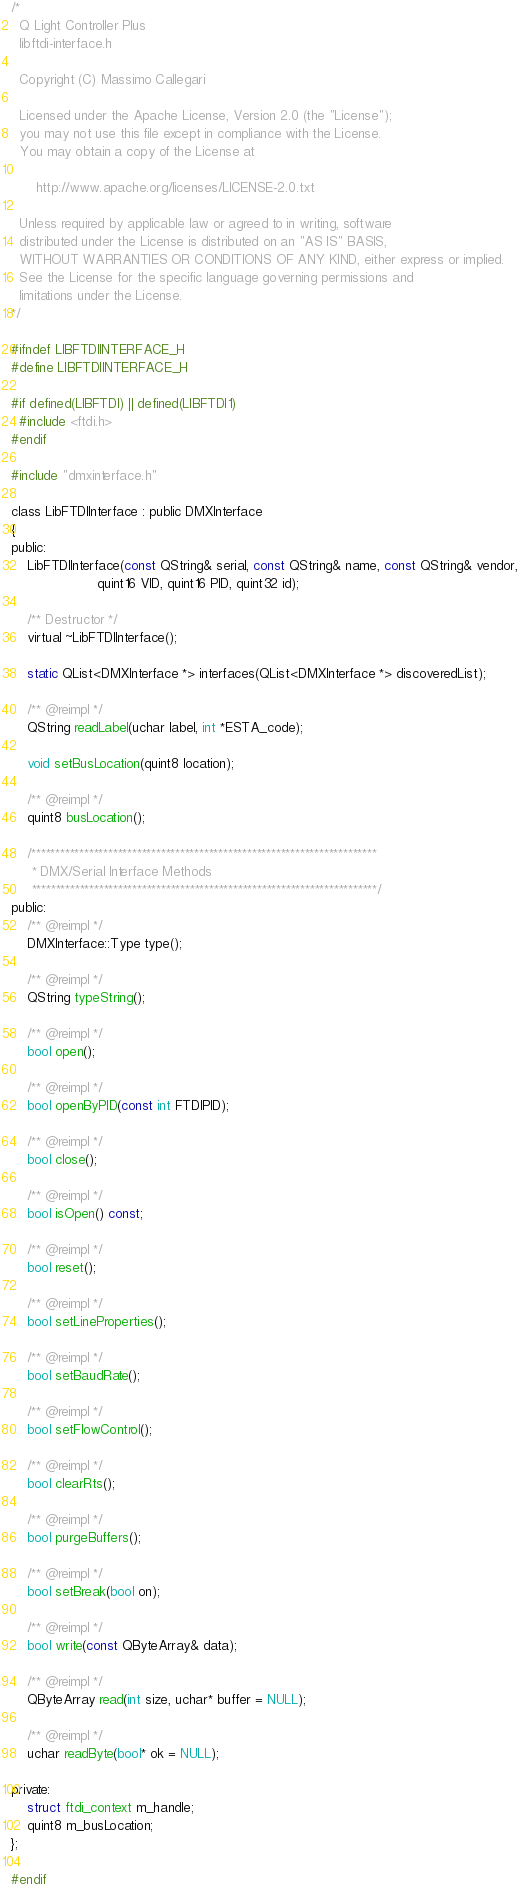Convert code to text. <code><loc_0><loc_0><loc_500><loc_500><_C_>/*
  Q Light Controller Plus
  libftdi-interface.h

  Copyright (C) Massimo Callegari

  Licensed under the Apache License, Version 2.0 (the "License");
  you may not use this file except in compliance with the License.
  You may obtain a copy of the License at

      http://www.apache.org/licenses/LICENSE-2.0.txt

  Unless required by applicable law or agreed to in writing, software
  distributed under the License is distributed on an "AS IS" BASIS,
  WITHOUT WARRANTIES OR CONDITIONS OF ANY KIND, either express or implied.
  See the License for the specific language governing permissions and
  limitations under the License.
*/

#ifndef LIBFTDIINTERFACE_H
#define LIBFTDIINTERFACE_H

#if defined(LIBFTDI) || defined(LIBFTDI1)
  #include <ftdi.h>
#endif

#include "dmxinterface.h"

class LibFTDIInterface : public DMXInterface
{
public:
    LibFTDIInterface(const QString& serial, const QString& name, const QString& vendor,
                     quint16 VID, quint16 PID, quint32 id);

    /** Destructor */
    virtual ~LibFTDIInterface();

    static QList<DMXInterface *> interfaces(QList<DMXInterface *> discoveredList);

    /** @reimpl */
    QString readLabel(uchar label, int *ESTA_code);

    void setBusLocation(quint8 location);

    /** @reimpl */
    quint8 busLocation();

    /************************************************************************
     * DMX/Serial Interface Methods
     ************************************************************************/
public:
    /** @reimpl */
    DMXInterface::Type type();

    /** @reimpl */
    QString typeString();

    /** @reimpl */
    bool open();

    /** @reimpl */
    bool openByPID(const int FTDIPID);

    /** @reimpl */
    bool close();

    /** @reimpl */
    bool isOpen() const;

    /** @reimpl */
    bool reset();

    /** @reimpl */
    bool setLineProperties();

    /** @reimpl */
    bool setBaudRate();

    /** @reimpl */
    bool setFlowControl();

    /** @reimpl */
    bool clearRts();

    /** @reimpl */
    bool purgeBuffers();

    /** @reimpl */
    bool setBreak(bool on);

    /** @reimpl */
    bool write(const QByteArray& data);

    /** @reimpl */
    QByteArray read(int size, uchar* buffer = NULL);

    /** @reimpl */
    uchar readByte(bool* ok = NULL);

private:
    struct ftdi_context m_handle;
    quint8 m_busLocation;
};

#endif
</code> 